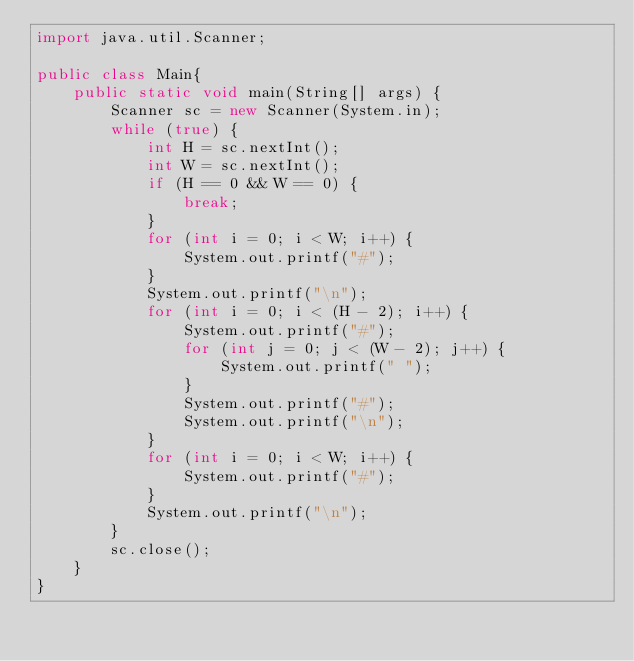<code> <loc_0><loc_0><loc_500><loc_500><_Java_>import java.util.Scanner;

public class Main{
	public static void main(String[] args) {
		Scanner sc = new Scanner(System.in);
		while (true) {
			int H = sc.nextInt();
			int W = sc.nextInt();
			if (H == 0 && W == 0) {
				break;
			}
			for (int i = 0; i < W; i++) {
				System.out.printf("#");
			}
			System.out.printf("\n");
			for (int i = 0; i < (H - 2); i++) {
				System.out.printf("#");
				for (int j = 0; j < (W - 2); j++) {
					System.out.printf(" ");
				}
				System.out.printf("#");
				System.out.printf("\n");
			}
			for (int i = 0; i < W; i++) {
				System.out.printf("#");
			}
			System.out.printf("\n");
		}
		sc.close();
	}
}</code> 